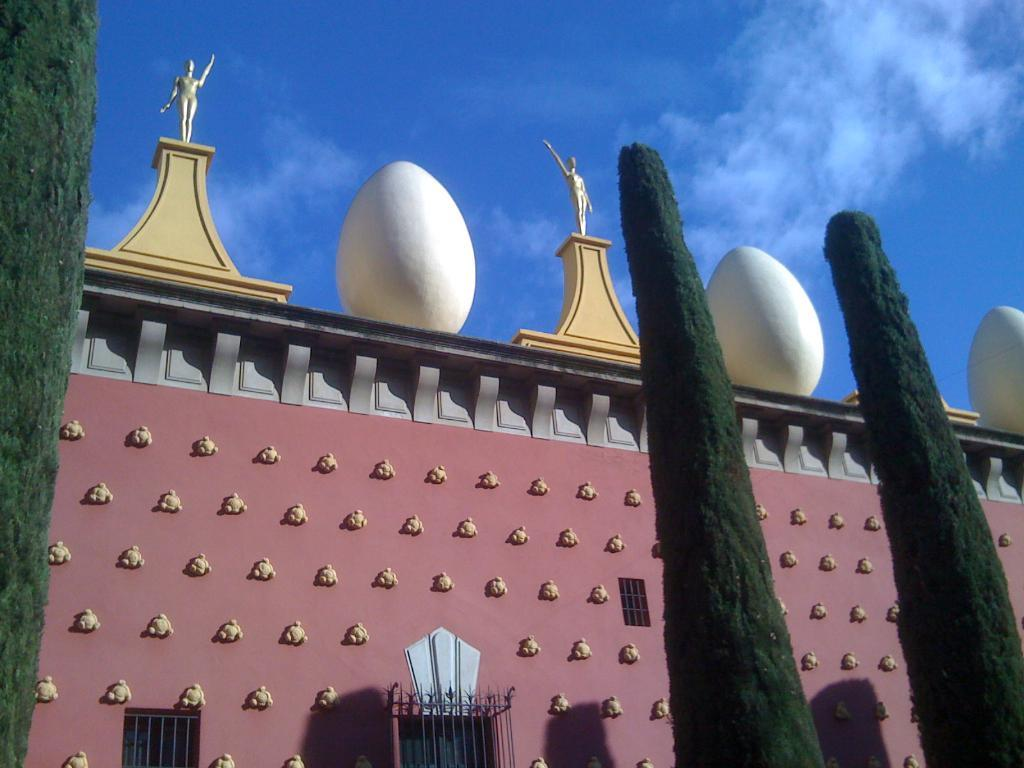What is the main structure in the image? There is a big building in the image. What decorative elements are present on the building? The building has sculptures on top. What type of vegetation is in front of the building? There are trees in front of the building. What type of lace can be seen on the book in the image? There is no book or lace present in the image; it features a big building with sculptures and trees. 